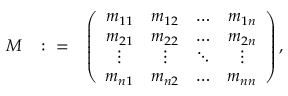<formula> <loc_0><loc_0><loc_500><loc_500>\begin{array} { r l r } { M } & { \colon = } & { \left ( \begin{array} { c c c c } { m _ { 1 1 } } & { m _ { 1 2 } } & { \hdots } & { m _ { 1 n } } \\ { m _ { 2 1 } } & { m _ { 2 2 } } & { \hdots } & { m _ { 2 n } } \\ { \vdots } & { \vdots } & { \ddots } & { \vdots } \\ { m _ { n 1 } } & { m _ { n 2 } } & { \hdots } & { m _ { n n } } \end{array} \right ) , } \end{array}</formula> 